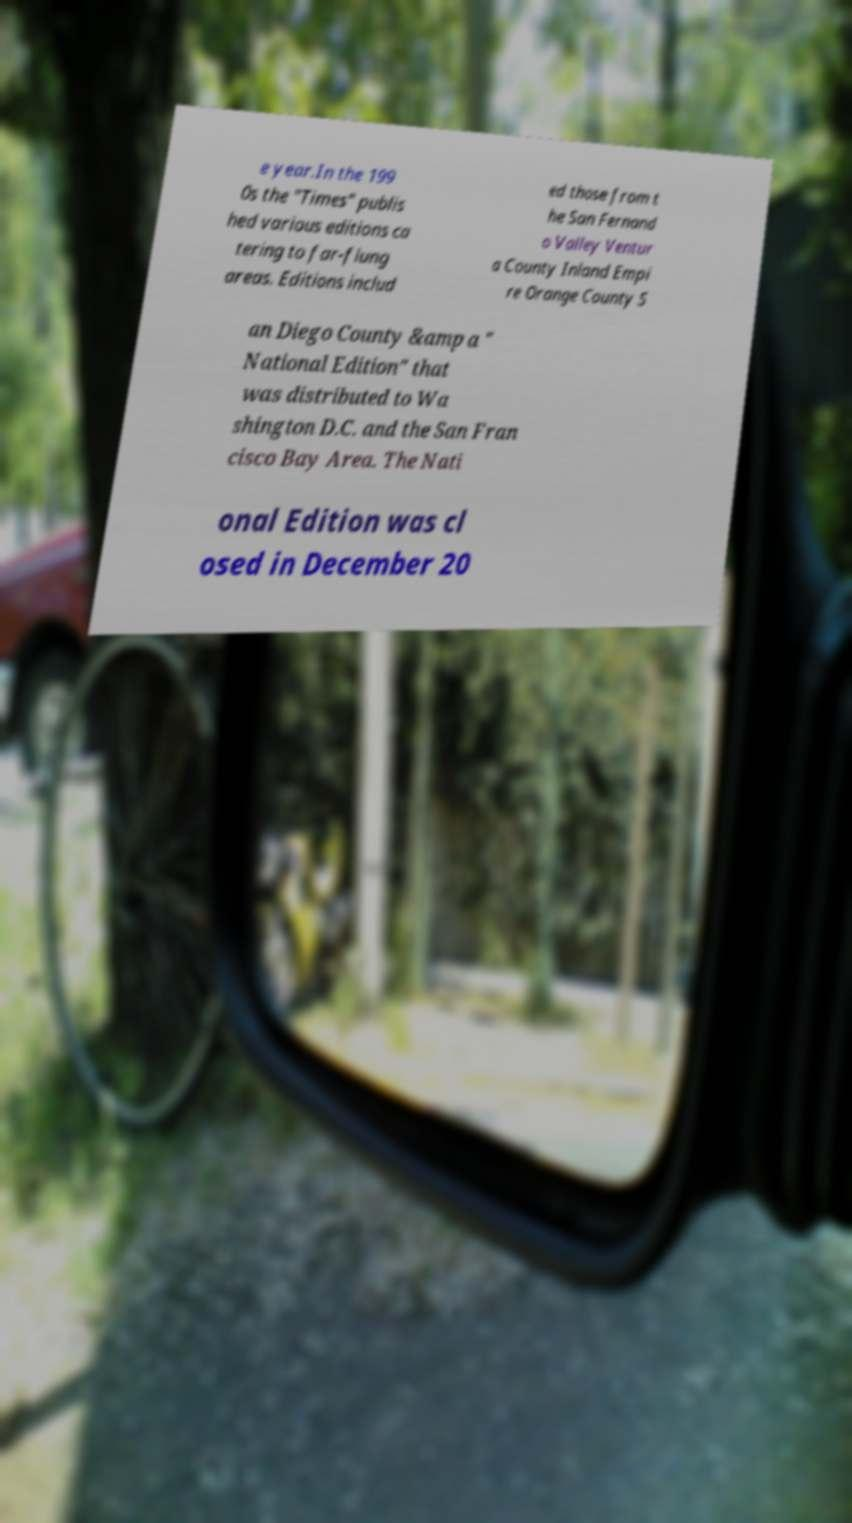Can you read and provide the text displayed in the image?This photo seems to have some interesting text. Can you extract and type it out for me? e year.In the 199 0s the "Times" publis hed various editions ca tering to far-flung areas. Editions includ ed those from t he San Fernand o Valley Ventur a County Inland Empi re Orange County S an Diego County &amp a " National Edition" that was distributed to Wa shington D.C. and the San Fran cisco Bay Area. The Nati onal Edition was cl osed in December 20 